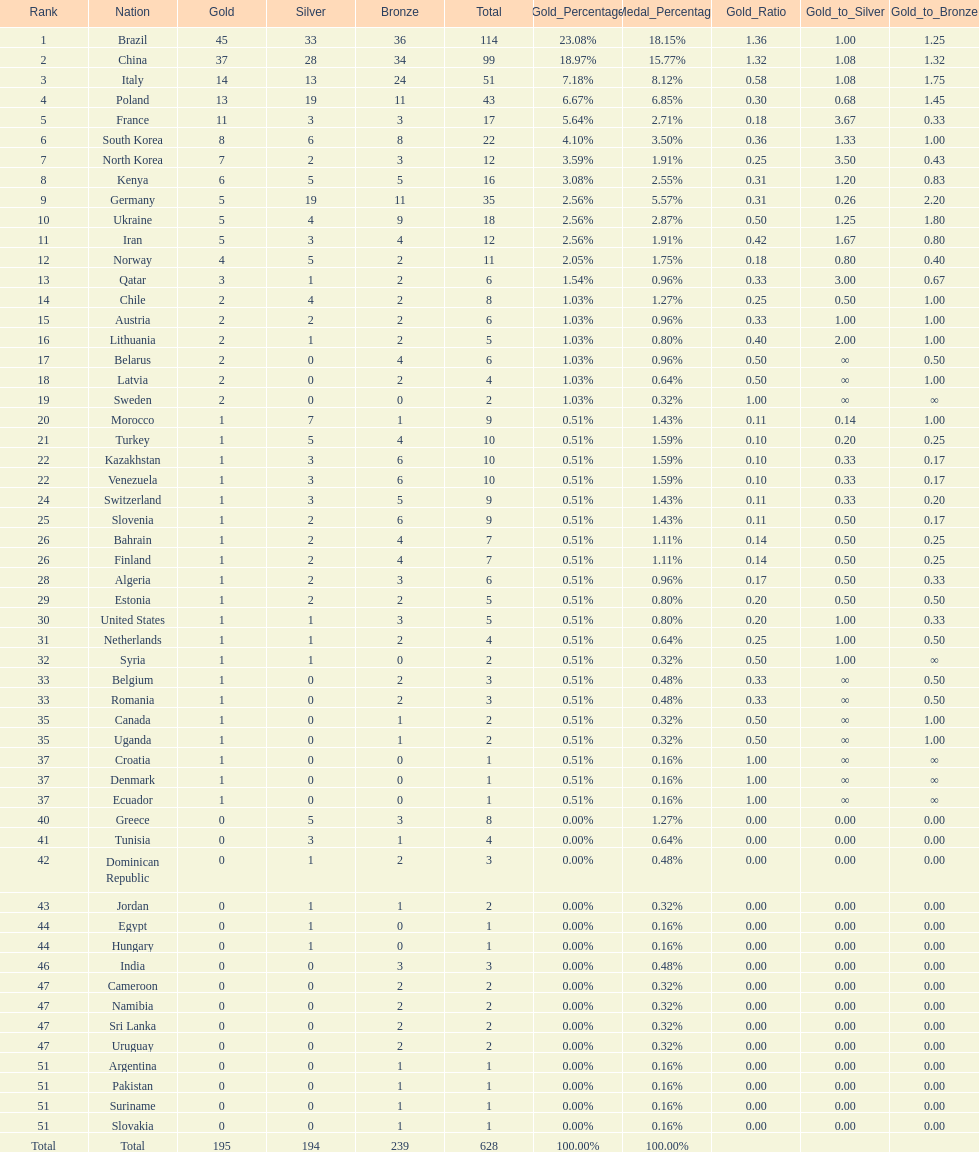Who only won 13 silver medals? Italy. Could you parse the entire table? {'header': ['Rank', 'Nation', 'Gold', 'Silver', 'Bronze', 'Total', 'Gold_Percentage', 'Medal_Percentage', 'Gold_Ratio', 'Gold_to_Silver', 'Gold_to_Bronze'], 'rows': [['1', 'Brazil', '45', '33', '36', '114', '23.08%', '18.15%', '1.36', '1.00', '1.25'], ['2', 'China', '37', '28', '34', '99', '18.97%', '15.77%', '1.32', '1.08', '1.32'], ['3', 'Italy', '14', '13', '24', '51', '7.18%', '8.12%', '0.58', '1.08', '1.75'], ['4', 'Poland', '13', '19', '11', '43', '6.67%', '6.85%', '0.30', '0.68', '1.45'], ['5', 'France', '11', '3', '3', '17', '5.64%', '2.71%', '0.18', '3.67', '0.33'], ['6', 'South Korea', '8', '6', '8', '22', '4.10%', '3.50%', '0.36', '1.33', '1.00'], ['7', 'North Korea', '7', '2', '3', '12', '3.59%', '1.91%', '0.25', '3.50', '0.43'], ['8', 'Kenya', '6', '5', '5', '16', '3.08%', '2.55%', '0.31', '1.20', '0.83'], ['9', 'Germany', '5', '19', '11', '35', '2.56%', '5.57%', '0.31', '0.26', '2.20'], ['10', 'Ukraine', '5', '4', '9', '18', '2.56%', '2.87%', '0.50', '1.25', '1.80'], ['11', 'Iran', '5', '3', '4', '12', '2.56%', '1.91%', '0.42', '1.67', '0.80'], ['12', 'Norway', '4', '5', '2', '11', '2.05%', '1.75%', '0.18', '0.80', '0.40'], ['13', 'Qatar', '3', '1', '2', '6', '1.54%', '0.96%', '0.33', '3.00', '0.67'], ['14', 'Chile', '2', '4', '2', '8', '1.03%', '1.27%', '0.25', '0.50', '1.00'], ['15', 'Austria', '2', '2', '2', '6', '1.03%', '0.96%', '0.33', '1.00', '1.00'], ['16', 'Lithuania', '2', '1', '2', '5', '1.03%', '0.80%', '0.40', '2.00', '1.00'], ['17', 'Belarus', '2', '0', '4', '6', '1.03%', '0.96%', '0.50', '∞', '0.50'], ['18', 'Latvia', '2', '0', '2', '4', '1.03%', '0.64%', '0.50', '∞', '1.00'], ['19', 'Sweden', '2', '0', '0', '2', '1.03%', '0.32%', '1.00', '∞', '∞'], ['20', 'Morocco', '1', '7', '1', '9', '0.51%', '1.43%', '0.11', '0.14', '1.00'], ['21', 'Turkey', '1', '5', '4', '10', '0.51%', '1.59%', '0.10', '0.20', '0.25'], ['22', 'Kazakhstan', '1', '3', '6', '10', '0.51%', '1.59%', '0.10', '0.33', '0.17'], ['22', 'Venezuela', '1', '3', '6', '10', '0.51%', '1.59%', '0.10', '0.33', '0.17'], ['24', 'Switzerland', '1', '3', '5', '9', '0.51%', '1.43%', '0.11', '0.33', '0.20'], ['25', 'Slovenia', '1', '2', '6', '9', '0.51%', '1.43%', '0.11', '0.50', '0.17'], ['26', 'Bahrain', '1', '2', '4', '7', '0.51%', '1.11%', '0.14', '0.50', '0.25'], ['26', 'Finland', '1', '2', '4', '7', '0.51%', '1.11%', '0.14', '0.50', '0.25'], ['28', 'Algeria', '1', '2', '3', '6', '0.51%', '0.96%', '0.17', '0.50', '0.33'], ['29', 'Estonia', '1', '2', '2', '5', '0.51%', '0.80%', '0.20', '0.50', '0.50'], ['30', 'United States', '1', '1', '3', '5', '0.51%', '0.80%', '0.20', '1.00', '0.33'], ['31', 'Netherlands', '1', '1', '2', '4', '0.51%', '0.64%', '0.25', '1.00', '0.50'], ['32', 'Syria', '1', '1', '0', '2', '0.51%', '0.32%', '0.50', '1.00', '∞'], ['33', 'Belgium', '1', '0', '2', '3', '0.51%', '0.48%', '0.33', '∞', '0.50'], ['33', 'Romania', '1', '0', '2', '3', '0.51%', '0.48%', '0.33', '∞', '0.50'], ['35', 'Canada', '1', '0', '1', '2', '0.51%', '0.32%', '0.50', '∞', '1.00'], ['35', 'Uganda', '1', '0', '1', '2', '0.51%', '0.32%', '0.50', '∞', '1.00'], ['37', 'Croatia', '1', '0', '0', '1', '0.51%', '0.16%', '1.00', '∞', '∞'], ['37', 'Denmark', '1', '0', '0', '1', '0.51%', '0.16%', '1.00', '∞', '∞'], ['37', 'Ecuador', '1', '0', '0', '1', '0.51%', '0.16%', '1.00', '∞', '∞'], ['40', 'Greece', '0', '5', '3', '8', '0.00%', '1.27%', '0.00', '0.00', '0.00'], ['41', 'Tunisia', '0', '3', '1', '4', '0.00%', '0.64%', '0.00', '0.00', '0.00'], ['42', 'Dominican Republic', '0', '1', '2', '3', '0.00%', '0.48%', '0.00', '0.00', '0.00'], ['43', 'Jordan', '0', '1', '1', '2', '0.00%', '0.32%', '0.00', '0.00', '0.00'], ['44', 'Egypt', '0', '1', '0', '1', '0.00%', '0.16%', '0.00', '0.00', '0.00'], ['44', 'Hungary', '0', '1', '0', '1', '0.00%', '0.16%', '0.00', '0.00', '0.00'], ['46', 'India', '0', '0', '3', '3', '0.00%', '0.48%', '0.00', '0.00', '0.00'], ['47', 'Cameroon', '0', '0', '2', '2', '0.00%', '0.32%', '0.00', '0.00', '0.00'], ['47', 'Namibia', '0', '0', '2', '2', '0.00%', '0.32%', '0.00', '0.00', '0.00'], ['47', 'Sri Lanka', '0', '0', '2', '2', '0.00%', '0.32%', '0.00', '0.00', '0.00'], ['47', 'Uruguay', '0', '0', '2', '2', '0.00%', '0.32%', '0.00', '0.00', '0.00'], ['51', 'Argentina', '0', '0', '1', '1', '0.00%', '0.16%', '0.00', '0.00', '0.00'], ['51', 'Pakistan', '0', '0', '1', '1', '0.00%', '0.16%', '0.00', '0.00', '0.00'], ['51', 'Suriname', '0', '0', '1', '1', '0.00%', '0.16%', '0.00', '0.00', '0.00'], ['51', 'Slovakia', '0', '0', '1', '1', '0.00%', '0.16%', '0.00', '0.00', '0.00'], ['Total', 'Total', '195', '194', '239', '628', '100.00%', '100.00%', '', '', '']]} 